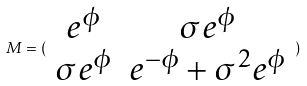<formula> <loc_0><loc_0><loc_500><loc_500>M = ( \begin{array} { c c } e ^ { \phi } & \sigma e ^ { \phi } \\ \sigma e ^ { \phi } & e ^ { - \phi } + \sigma ^ { 2 } e ^ { \phi } \end{array} )</formula> 